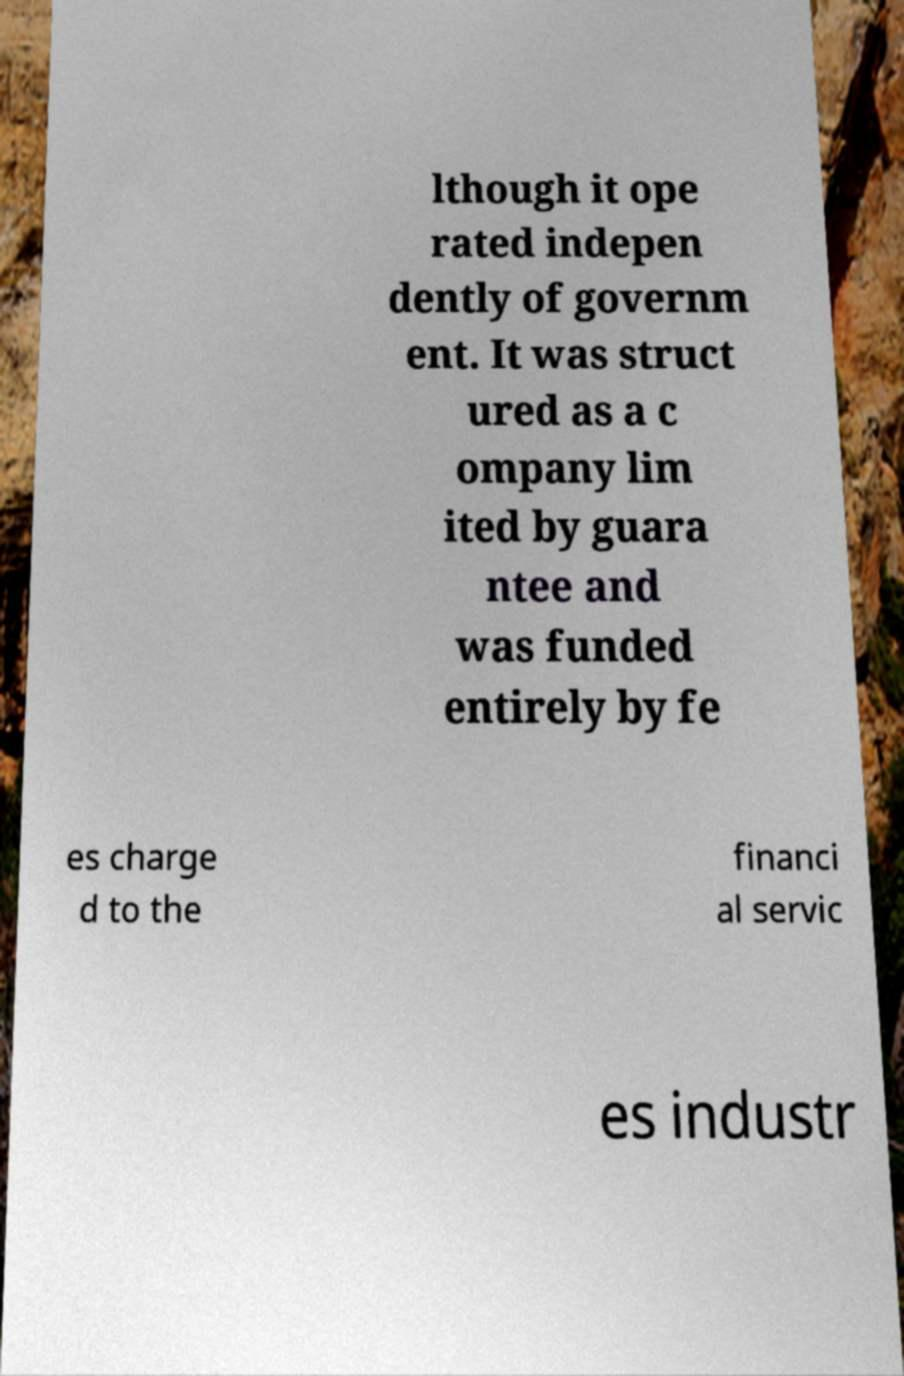Can you read and provide the text displayed in the image?This photo seems to have some interesting text. Can you extract and type it out for me? lthough it ope rated indepen dently of governm ent. It was struct ured as a c ompany lim ited by guara ntee and was funded entirely by fe es charge d to the financi al servic es industr 